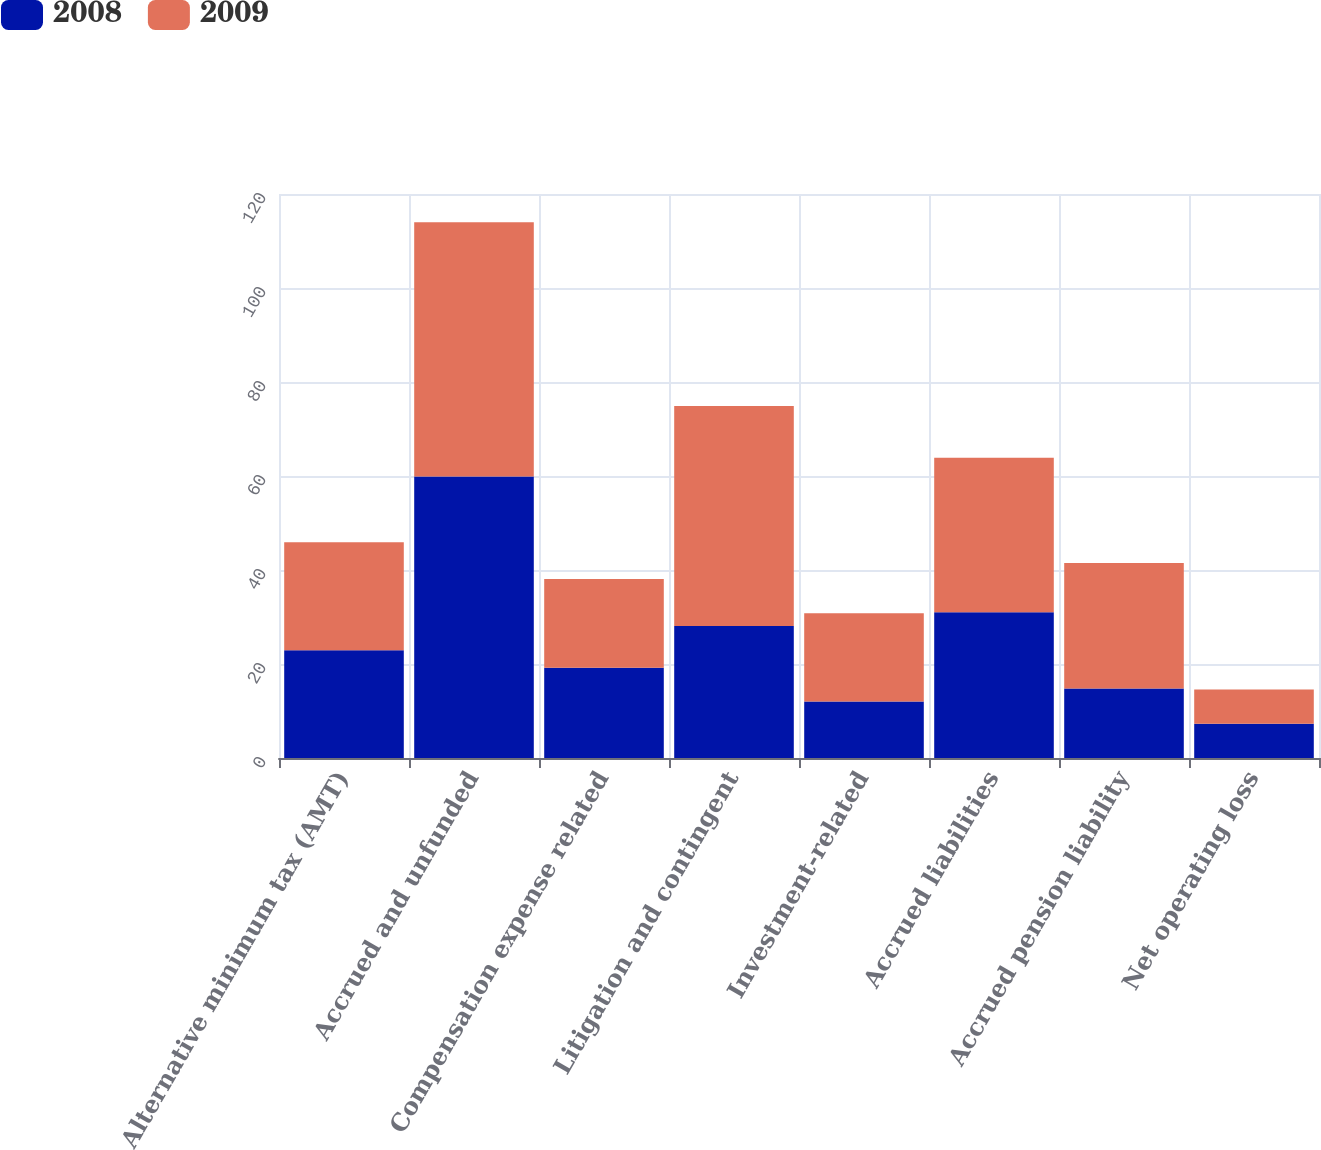<chart> <loc_0><loc_0><loc_500><loc_500><stacked_bar_chart><ecel><fcel>Alternative minimum tax (AMT)<fcel>Accrued and unfunded<fcel>Compensation expense related<fcel>Litigation and contingent<fcel>Investment-related<fcel>Accrued liabilities<fcel>Accrued pension liability<fcel>Net operating loss<nl><fcel>2008<fcel>22.95<fcel>59.9<fcel>19.2<fcel>28.1<fcel>12<fcel>31<fcel>14.8<fcel>7.3<nl><fcel>2009<fcel>22.95<fcel>54.1<fcel>18.9<fcel>46.8<fcel>18.8<fcel>32.9<fcel>26.7<fcel>7.3<nl></chart> 